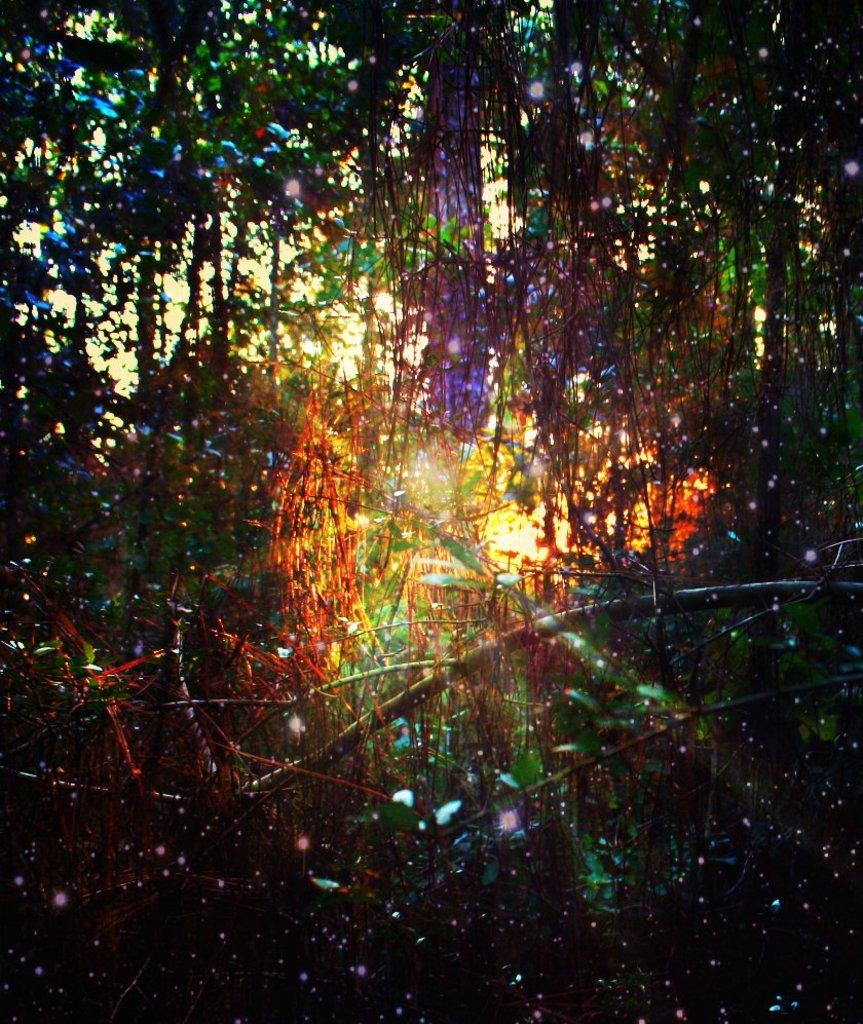What type of vegetation can be seen in the image? There are trees in the image. What is the source of light in the image? Sunlight is visible in between the trees. How many times do the trees form a complete circle in the image? The trees do not form a complete circle in the image; they are scattered and not arranged in a circular pattern. 